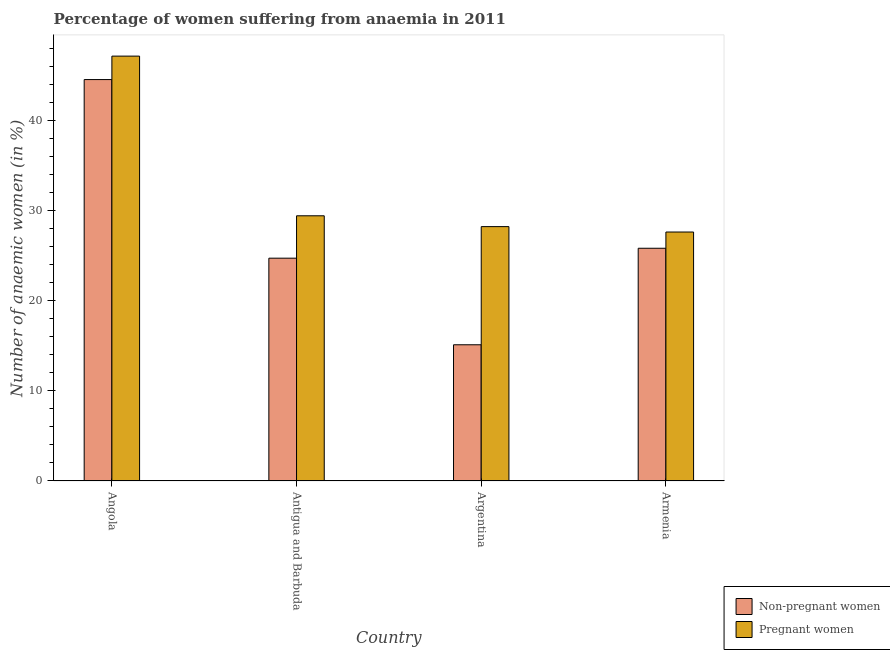How many groups of bars are there?
Provide a short and direct response. 4. Are the number of bars on each tick of the X-axis equal?
Your answer should be compact. Yes. How many bars are there on the 3rd tick from the right?
Give a very brief answer. 2. What is the label of the 4th group of bars from the left?
Your response must be concise. Armenia. What is the percentage of pregnant anaemic women in Armenia?
Offer a very short reply. 27.6. Across all countries, what is the maximum percentage of non-pregnant anaemic women?
Ensure brevity in your answer.  44.5. Across all countries, what is the minimum percentage of pregnant anaemic women?
Your answer should be compact. 27.6. In which country was the percentage of non-pregnant anaemic women maximum?
Your response must be concise. Angola. In which country was the percentage of non-pregnant anaemic women minimum?
Offer a very short reply. Argentina. What is the total percentage of non-pregnant anaemic women in the graph?
Make the answer very short. 110.1. What is the difference between the percentage of pregnant anaemic women in Antigua and Barbuda and that in Argentina?
Give a very brief answer. 1.2. What is the difference between the percentage of pregnant anaemic women in Antigua and Barbuda and the percentage of non-pregnant anaemic women in Argentina?
Provide a succinct answer. 14.3. What is the average percentage of pregnant anaemic women per country?
Your answer should be very brief. 33.08. What is the difference between the percentage of non-pregnant anaemic women and percentage of pregnant anaemic women in Antigua and Barbuda?
Provide a succinct answer. -4.7. What is the ratio of the percentage of pregnant anaemic women in Angola to that in Antigua and Barbuda?
Make the answer very short. 1.6. Is the difference between the percentage of non-pregnant anaemic women in Angola and Antigua and Barbuda greater than the difference between the percentage of pregnant anaemic women in Angola and Antigua and Barbuda?
Ensure brevity in your answer.  Yes. What is the difference between the highest and the second highest percentage of non-pregnant anaemic women?
Give a very brief answer. 18.7. What is the difference between the highest and the lowest percentage of non-pregnant anaemic women?
Offer a terse response. 29.4. In how many countries, is the percentage of non-pregnant anaemic women greater than the average percentage of non-pregnant anaemic women taken over all countries?
Your response must be concise. 1. What does the 1st bar from the left in Argentina represents?
Give a very brief answer. Non-pregnant women. What does the 1st bar from the right in Armenia represents?
Provide a succinct answer. Pregnant women. Are the values on the major ticks of Y-axis written in scientific E-notation?
Ensure brevity in your answer.  No. Where does the legend appear in the graph?
Give a very brief answer. Bottom right. How are the legend labels stacked?
Make the answer very short. Vertical. What is the title of the graph?
Your response must be concise. Percentage of women suffering from anaemia in 2011. What is the label or title of the Y-axis?
Offer a terse response. Number of anaemic women (in %). What is the Number of anaemic women (in %) in Non-pregnant women in Angola?
Offer a very short reply. 44.5. What is the Number of anaemic women (in %) of Pregnant women in Angola?
Offer a very short reply. 47.1. What is the Number of anaemic women (in %) of Non-pregnant women in Antigua and Barbuda?
Give a very brief answer. 24.7. What is the Number of anaemic women (in %) in Pregnant women in Antigua and Barbuda?
Give a very brief answer. 29.4. What is the Number of anaemic women (in %) of Non-pregnant women in Argentina?
Your response must be concise. 15.1. What is the Number of anaemic women (in %) in Pregnant women in Argentina?
Provide a succinct answer. 28.2. What is the Number of anaemic women (in %) in Non-pregnant women in Armenia?
Give a very brief answer. 25.8. What is the Number of anaemic women (in %) of Pregnant women in Armenia?
Offer a very short reply. 27.6. Across all countries, what is the maximum Number of anaemic women (in %) in Non-pregnant women?
Your response must be concise. 44.5. Across all countries, what is the maximum Number of anaemic women (in %) of Pregnant women?
Your answer should be compact. 47.1. Across all countries, what is the minimum Number of anaemic women (in %) of Pregnant women?
Ensure brevity in your answer.  27.6. What is the total Number of anaemic women (in %) of Non-pregnant women in the graph?
Provide a succinct answer. 110.1. What is the total Number of anaemic women (in %) in Pregnant women in the graph?
Your answer should be compact. 132.3. What is the difference between the Number of anaemic women (in %) in Non-pregnant women in Angola and that in Antigua and Barbuda?
Keep it short and to the point. 19.8. What is the difference between the Number of anaemic women (in %) in Non-pregnant women in Angola and that in Argentina?
Provide a short and direct response. 29.4. What is the difference between the Number of anaemic women (in %) of Pregnant women in Angola and that in Argentina?
Offer a very short reply. 18.9. What is the difference between the Number of anaemic women (in %) of Non-pregnant women in Antigua and Barbuda and that in Argentina?
Give a very brief answer. 9.6. What is the difference between the Number of anaemic women (in %) of Pregnant women in Antigua and Barbuda and that in Armenia?
Offer a very short reply. 1.8. What is the difference between the Number of anaemic women (in %) in Non-pregnant women in Argentina and that in Armenia?
Ensure brevity in your answer.  -10.7. What is the difference between the Number of anaemic women (in %) of Pregnant women in Argentina and that in Armenia?
Your response must be concise. 0.6. What is the difference between the Number of anaemic women (in %) in Non-pregnant women in Angola and the Number of anaemic women (in %) in Pregnant women in Argentina?
Provide a succinct answer. 16.3. What is the difference between the Number of anaemic women (in %) of Non-pregnant women in Argentina and the Number of anaemic women (in %) of Pregnant women in Armenia?
Your answer should be compact. -12.5. What is the average Number of anaemic women (in %) of Non-pregnant women per country?
Offer a terse response. 27.52. What is the average Number of anaemic women (in %) in Pregnant women per country?
Your response must be concise. 33.08. What is the difference between the Number of anaemic women (in %) of Non-pregnant women and Number of anaemic women (in %) of Pregnant women in Antigua and Barbuda?
Your answer should be very brief. -4.7. What is the difference between the Number of anaemic women (in %) of Non-pregnant women and Number of anaemic women (in %) of Pregnant women in Argentina?
Offer a terse response. -13.1. What is the ratio of the Number of anaemic women (in %) in Non-pregnant women in Angola to that in Antigua and Barbuda?
Ensure brevity in your answer.  1.8. What is the ratio of the Number of anaemic women (in %) in Pregnant women in Angola to that in Antigua and Barbuda?
Provide a short and direct response. 1.6. What is the ratio of the Number of anaemic women (in %) in Non-pregnant women in Angola to that in Argentina?
Your answer should be very brief. 2.95. What is the ratio of the Number of anaemic women (in %) of Pregnant women in Angola to that in Argentina?
Offer a very short reply. 1.67. What is the ratio of the Number of anaemic women (in %) of Non-pregnant women in Angola to that in Armenia?
Keep it short and to the point. 1.72. What is the ratio of the Number of anaemic women (in %) in Pregnant women in Angola to that in Armenia?
Your answer should be very brief. 1.71. What is the ratio of the Number of anaemic women (in %) in Non-pregnant women in Antigua and Barbuda to that in Argentina?
Ensure brevity in your answer.  1.64. What is the ratio of the Number of anaemic women (in %) of Pregnant women in Antigua and Barbuda to that in Argentina?
Offer a very short reply. 1.04. What is the ratio of the Number of anaemic women (in %) of Non-pregnant women in Antigua and Barbuda to that in Armenia?
Provide a succinct answer. 0.96. What is the ratio of the Number of anaemic women (in %) in Pregnant women in Antigua and Barbuda to that in Armenia?
Give a very brief answer. 1.07. What is the ratio of the Number of anaemic women (in %) in Non-pregnant women in Argentina to that in Armenia?
Offer a very short reply. 0.59. What is the ratio of the Number of anaemic women (in %) in Pregnant women in Argentina to that in Armenia?
Make the answer very short. 1.02. What is the difference between the highest and the second highest Number of anaemic women (in %) in Non-pregnant women?
Provide a short and direct response. 18.7. What is the difference between the highest and the lowest Number of anaemic women (in %) in Non-pregnant women?
Your response must be concise. 29.4. What is the difference between the highest and the lowest Number of anaemic women (in %) in Pregnant women?
Make the answer very short. 19.5. 